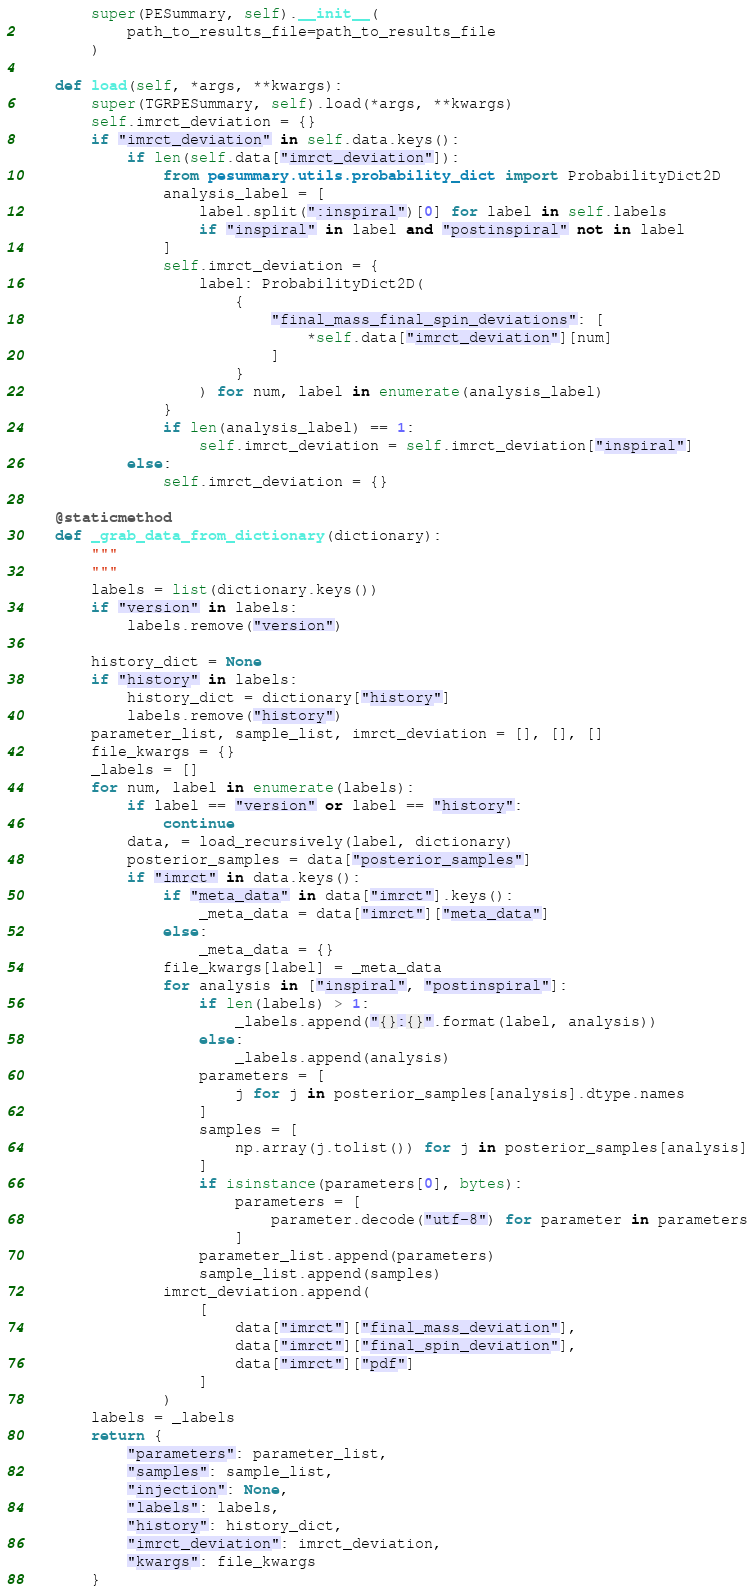Convert code to text. <code><loc_0><loc_0><loc_500><loc_500><_Python_>        super(PESummary, self).__init__(
            path_to_results_file=path_to_results_file
        )

    def load(self, *args, **kwargs):
        super(TGRPESummary, self).load(*args, **kwargs)
        self.imrct_deviation = {}
        if "imrct_deviation" in self.data.keys():
            if len(self.data["imrct_deviation"]):
                from pesummary.utils.probability_dict import ProbabilityDict2D
                analysis_label = [
                    label.split(":inspiral")[0] for label in self.labels
                    if "inspiral" in label and "postinspiral" not in label
                ]
                self.imrct_deviation = {
                    label: ProbabilityDict2D(
                        {
                            "final_mass_final_spin_deviations": [
                                *self.data["imrct_deviation"][num]
                            ]
                        }
                    ) for num, label in enumerate(analysis_label)
                }
                if len(analysis_label) == 1:
                    self.imrct_deviation = self.imrct_deviation["inspiral"]
            else:
                self.imrct_deviation = {}

    @staticmethod
    def _grab_data_from_dictionary(dictionary):
        """
        """
        labels = list(dictionary.keys())
        if "version" in labels:
            labels.remove("version")

        history_dict = None
        if "history" in labels:
            history_dict = dictionary["history"]
            labels.remove("history")
        parameter_list, sample_list, imrct_deviation = [], [], []
        file_kwargs = {}
        _labels = []
        for num, label in enumerate(labels):
            if label == "version" or label == "history":
                continue
            data, = load_recursively(label, dictionary)
            posterior_samples = data["posterior_samples"]
            if "imrct" in data.keys():
                if "meta_data" in data["imrct"].keys():
                    _meta_data = data["imrct"]["meta_data"]
                else:
                    _meta_data = {}
                file_kwargs[label] = _meta_data
                for analysis in ["inspiral", "postinspiral"]:
                    if len(labels) > 1:
                        _labels.append("{}:{}".format(label, analysis))
                    else:
                        _labels.append(analysis)
                    parameters = [
                        j for j in posterior_samples[analysis].dtype.names
                    ]
                    samples = [
                        np.array(j.tolist()) for j in posterior_samples[analysis]
                    ]
                    if isinstance(parameters[0], bytes):
                        parameters = [
                            parameter.decode("utf-8") for parameter in parameters
                        ]
                    parameter_list.append(parameters)
                    sample_list.append(samples)
                imrct_deviation.append(
                    [
                        data["imrct"]["final_mass_deviation"],
                        data["imrct"]["final_spin_deviation"],
                        data["imrct"]["pdf"]
                    ]
                )
        labels = _labels
        return {
            "parameters": parameter_list,
            "samples": sample_list,
            "injection": None,
            "labels": labels,
            "history": history_dict,
            "imrct_deviation": imrct_deviation,
            "kwargs": file_kwargs
        }
</code> 